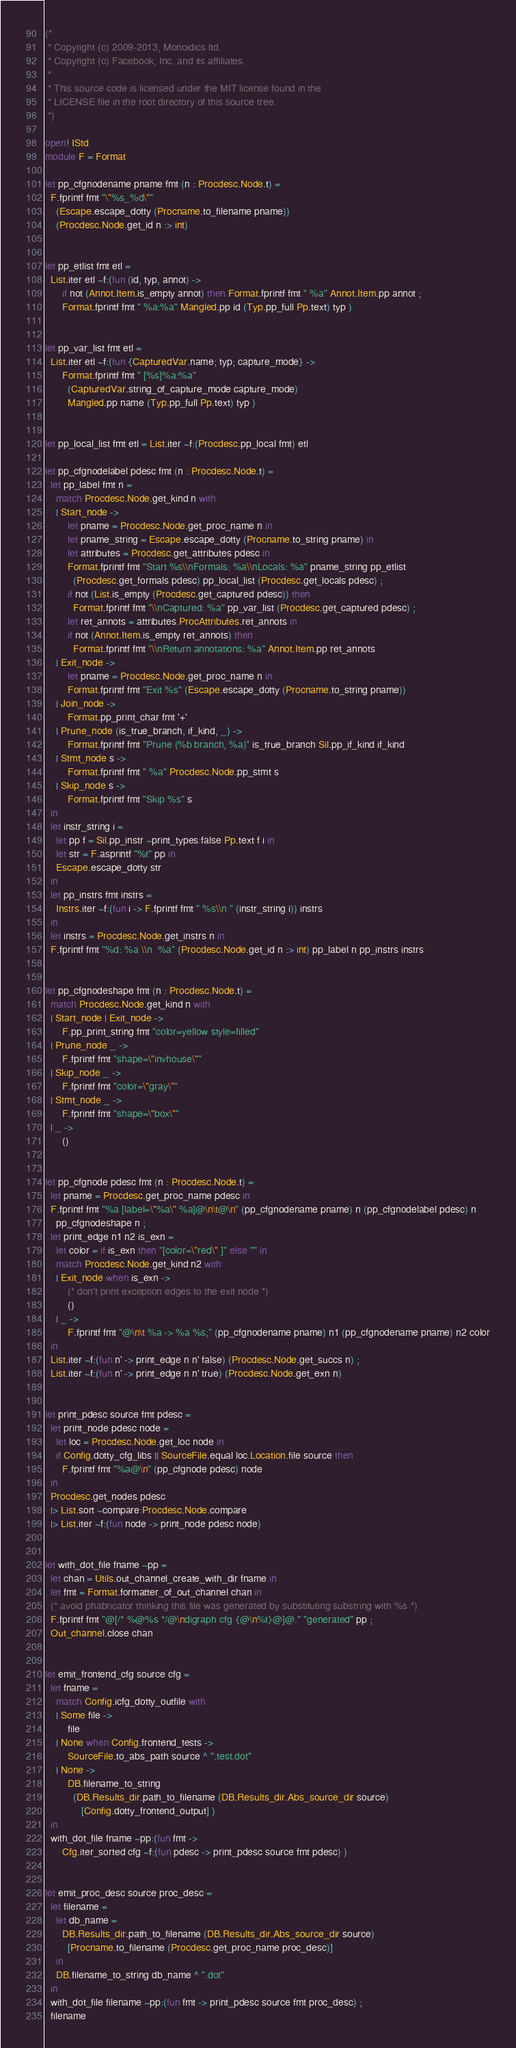Convert code to text. <code><loc_0><loc_0><loc_500><loc_500><_OCaml_>(*
 * Copyright (c) 2009-2013, Monoidics ltd.
 * Copyright (c) Facebook, Inc. and its affiliates.
 *
 * This source code is licensed under the MIT license found in the
 * LICENSE file in the root directory of this source tree.
 *)

open! IStd
module F = Format

let pp_cfgnodename pname fmt (n : Procdesc.Node.t) =
  F.fprintf fmt "\"%s_%d\""
    (Escape.escape_dotty (Procname.to_filename pname))
    (Procdesc.Node.get_id n :> int)


let pp_etlist fmt etl =
  List.iter etl ~f:(fun (id, typ, annot) ->
      if not (Annot.Item.is_empty annot) then Format.fprintf fmt " %a" Annot.Item.pp annot ;
      Format.fprintf fmt " %a:%a" Mangled.pp id (Typ.pp_full Pp.text) typ )


let pp_var_list fmt etl =
  List.iter etl ~f:(fun {CapturedVar.name; typ; capture_mode} ->
      Format.fprintf fmt " [%s]%a:%a"
        (CapturedVar.string_of_capture_mode capture_mode)
        Mangled.pp name (Typ.pp_full Pp.text) typ )


let pp_local_list fmt etl = List.iter ~f:(Procdesc.pp_local fmt) etl

let pp_cfgnodelabel pdesc fmt (n : Procdesc.Node.t) =
  let pp_label fmt n =
    match Procdesc.Node.get_kind n with
    | Start_node ->
        let pname = Procdesc.Node.get_proc_name n in
        let pname_string = Escape.escape_dotty (Procname.to_string pname) in
        let attributes = Procdesc.get_attributes pdesc in
        Format.fprintf fmt "Start %s\\nFormals: %a\\nLocals: %a" pname_string pp_etlist
          (Procdesc.get_formals pdesc) pp_local_list (Procdesc.get_locals pdesc) ;
        if not (List.is_empty (Procdesc.get_captured pdesc)) then
          Format.fprintf fmt "\\nCaptured: %a" pp_var_list (Procdesc.get_captured pdesc) ;
        let ret_annots = attributes.ProcAttributes.ret_annots in
        if not (Annot.Item.is_empty ret_annots) then
          Format.fprintf fmt "\\nReturn annotations: %a" Annot.Item.pp ret_annots
    | Exit_node ->
        let pname = Procdesc.Node.get_proc_name n in
        Format.fprintf fmt "Exit %s" (Escape.escape_dotty (Procname.to_string pname))
    | Join_node ->
        Format.pp_print_char fmt '+'
    | Prune_node (is_true_branch, if_kind, _) ->
        Format.fprintf fmt "Prune (%b branch, %a)" is_true_branch Sil.pp_if_kind if_kind
    | Stmt_node s ->
        Format.fprintf fmt " %a" Procdesc.Node.pp_stmt s
    | Skip_node s ->
        Format.fprintf fmt "Skip %s" s
  in
  let instr_string i =
    let pp f = Sil.pp_instr ~print_types:false Pp.text f i in
    let str = F.asprintf "%t" pp in
    Escape.escape_dotty str
  in
  let pp_instrs fmt instrs =
    Instrs.iter ~f:(fun i -> F.fprintf fmt " %s\\n " (instr_string i)) instrs
  in
  let instrs = Procdesc.Node.get_instrs n in
  F.fprintf fmt "%d: %a \\n  %a" (Procdesc.Node.get_id n :> int) pp_label n pp_instrs instrs


let pp_cfgnodeshape fmt (n : Procdesc.Node.t) =
  match Procdesc.Node.get_kind n with
  | Start_node | Exit_node ->
      F.pp_print_string fmt "color=yellow style=filled"
  | Prune_node _ ->
      F.fprintf fmt "shape=\"invhouse\""
  | Skip_node _ ->
      F.fprintf fmt "color=\"gray\""
  | Stmt_node _ ->
      F.fprintf fmt "shape=\"box\""
  | _ ->
      ()


let pp_cfgnode pdesc fmt (n : Procdesc.Node.t) =
  let pname = Procdesc.get_proc_name pdesc in
  F.fprintf fmt "%a [label=\"%a\" %a]@\n\t@\n" (pp_cfgnodename pname) n (pp_cfgnodelabel pdesc) n
    pp_cfgnodeshape n ;
  let print_edge n1 n2 is_exn =
    let color = if is_exn then "[color=\"red\" ]" else "" in
    match Procdesc.Node.get_kind n2 with
    | Exit_node when is_exn ->
        (* don't print exception edges to the exit node *)
        ()
    | _ ->
        F.fprintf fmt "@\n\t %a -> %a %s;" (pp_cfgnodename pname) n1 (pp_cfgnodename pname) n2 color
  in
  List.iter ~f:(fun n' -> print_edge n n' false) (Procdesc.Node.get_succs n) ;
  List.iter ~f:(fun n' -> print_edge n n' true) (Procdesc.Node.get_exn n)


let print_pdesc source fmt pdesc =
  let print_node pdesc node =
    let loc = Procdesc.Node.get_loc node in
    if Config.dotty_cfg_libs || SourceFile.equal loc.Location.file source then
      F.fprintf fmt "%a@\n" (pp_cfgnode pdesc) node
  in
  Procdesc.get_nodes pdesc
  |> List.sort ~compare:Procdesc.Node.compare
  |> List.iter ~f:(fun node -> print_node pdesc node)


let with_dot_file fname ~pp =
  let chan = Utils.out_channel_create_with_dir fname in
  let fmt = Format.formatter_of_out_channel chan in
  (* avoid phabricator thinking this file was generated by substituting substring with %s *)
  F.fprintf fmt "@[/* %@%s */@\ndigraph cfg {@\n%t}@]@." "generated" pp ;
  Out_channel.close chan


let emit_frontend_cfg source cfg =
  let fname =
    match Config.icfg_dotty_outfile with
    | Some file ->
        file
    | None when Config.frontend_tests ->
        SourceFile.to_abs_path source ^ ".test.dot"
    | None ->
        DB.filename_to_string
          (DB.Results_dir.path_to_filename (DB.Results_dir.Abs_source_dir source)
             [Config.dotty_frontend_output] )
  in
  with_dot_file fname ~pp:(fun fmt ->
      Cfg.iter_sorted cfg ~f:(fun pdesc -> print_pdesc source fmt pdesc) )


let emit_proc_desc source proc_desc =
  let filename =
    let db_name =
      DB.Results_dir.path_to_filename (DB.Results_dir.Abs_source_dir source)
        [Procname.to_filename (Procdesc.get_proc_name proc_desc)]
    in
    DB.filename_to_string db_name ^ ".dot"
  in
  with_dot_file filename ~pp:(fun fmt -> print_pdesc source fmt proc_desc) ;
  filename
</code> 